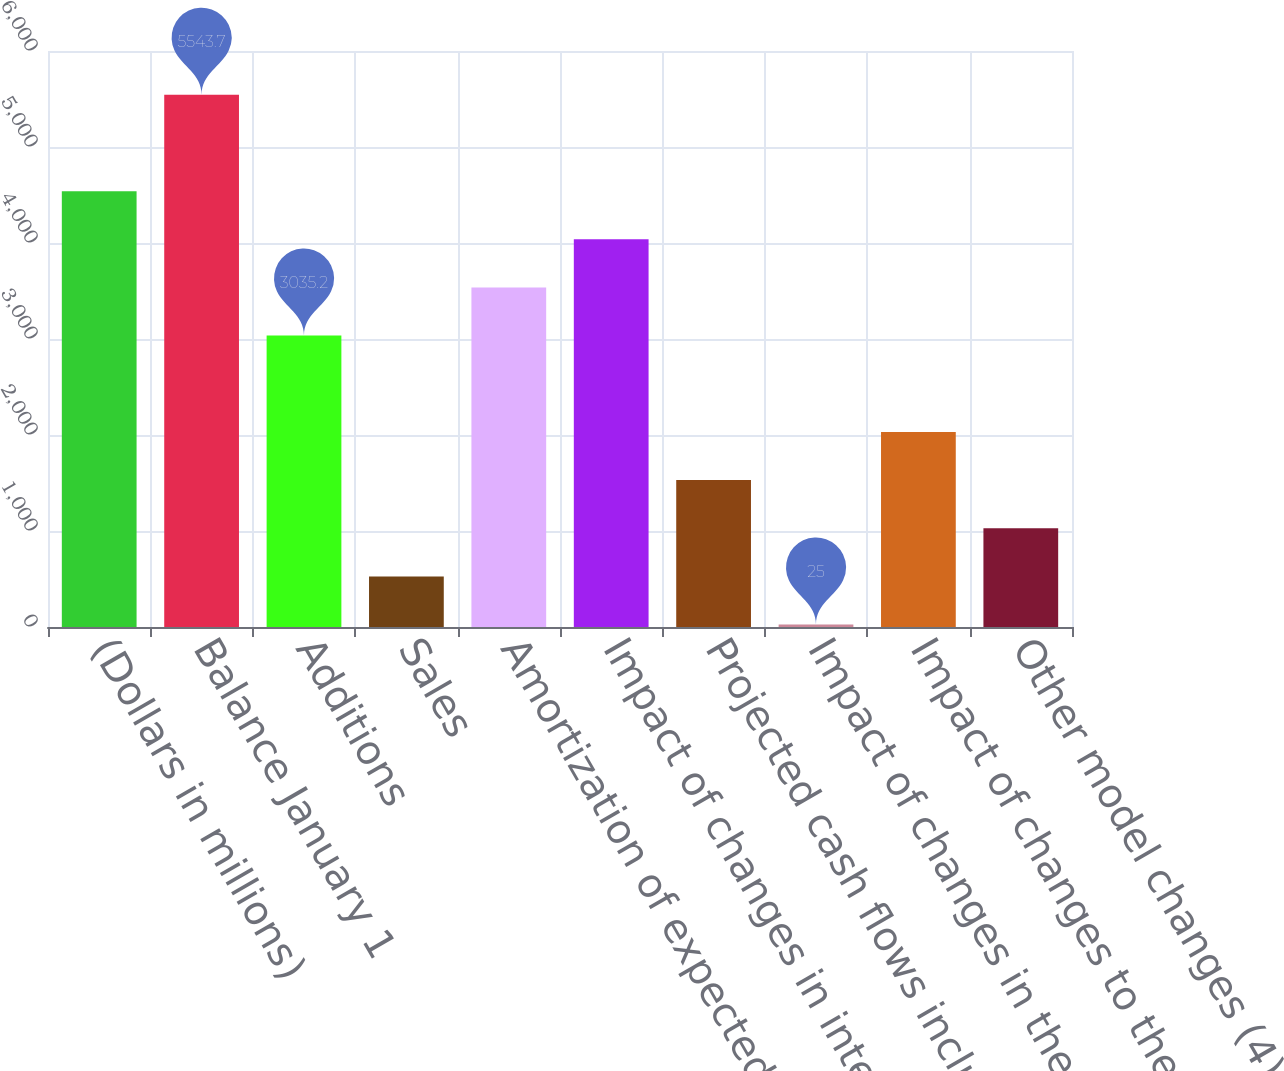<chart> <loc_0><loc_0><loc_500><loc_500><bar_chart><fcel>(Dollars in millions)<fcel>Balance January 1<fcel>Additions<fcel>Sales<fcel>Amortization of expected cash<fcel>Impact of changes in interest<fcel>Projected cash flows including<fcel>Impact of changes in the Home<fcel>Impact of changes to the<fcel>Other model changes (4)<nl><fcel>4540.3<fcel>5543.7<fcel>3035.2<fcel>526.7<fcel>3536.9<fcel>4038.6<fcel>1530.1<fcel>25<fcel>2031.8<fcel>1028.4<nl></chart> 